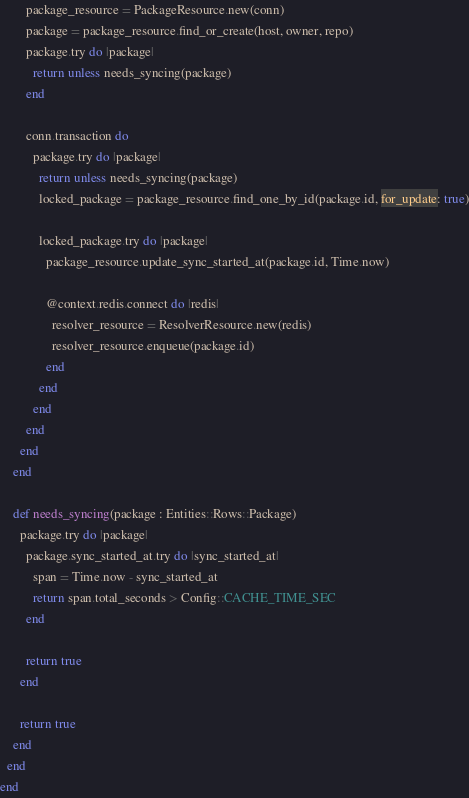Convert code to text. <code><loc_0><loc_0><loc_500><loc_500><_Crystal_>        package_resource = PackageResource.new(conn)
        package = package_resource.find_or_create(host, owner, repo)
        package.try do |package|
          return unless needs_syncing(package)
        end

        conn.transaction do
          package.try do |package|
            return unless needs_syncing(package)
            locked_package = package_resource.find_one_by_id(package.id, for_update: true)

            locked_package.try do |package|
              package_resource.update_sync_started_at(package.id, Time.now)

              @context.redis.connect do |redis|
                resolver_resource = ResolverResource.new(redis)
                resolver_resource.enqueue(package.id)
              end
            end
          end
        end
      end
    end

    def needs_syncing(package : Entities::Rows::Package)
      package.try do |package|
        package.sync_started_at.try do |sync_started_at|
          span = Time.now - sync_started_at
          return span.total_seconds > Config::CACHE_TIME_SEC
        end

        return true
      end

      return true
    end
  end
end
</code> 